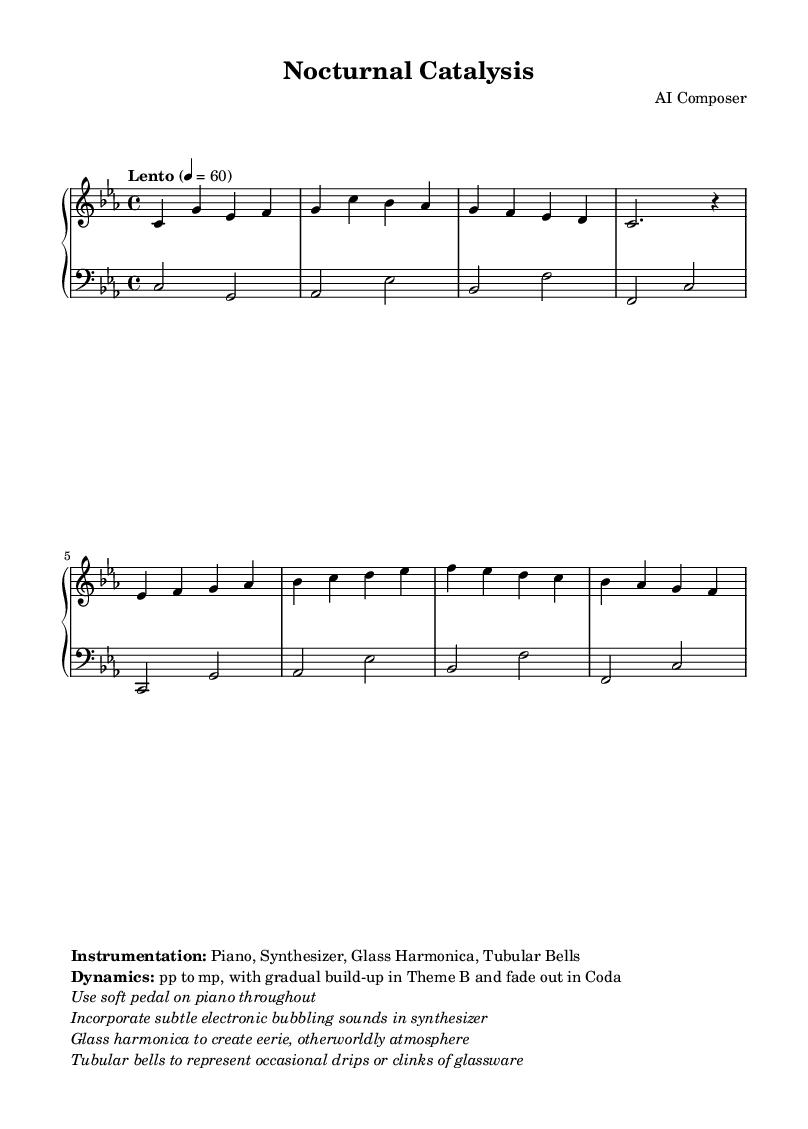What is the key signature of this music? The key signature is C minor, which has three flats (B♭, E♭, A♭). This can be determined by looking at the key signature marking at the beginning of the staff.
Answer: C minor What is the time signature of the piece? The time signature is 4/4, indicating that there are four beats in a measure and a quarter note gets one beat. This can be observed in the time signature marking at the beginning of the score.
Answer: 4/4 What is the tempo marking of the music? The tempo marking is "Lento," which means slowly. This is specified in the tempo indication at the beginning of the score, with the metronome marking of 60 beats per minute.
Answer: Lento How many instruments are specified in the instrumentation? The sheet music specifies four instruments: Piano, Synthesizer, Glass Harmonica, and Tubular Bells. This information is provided in the markup section where instrumentation is listed.
Answer: Four What dynamic markings are indicated in the score? The dynamic markings indicate "pp to mp" which refers to piano (soft) to mezzo-piano (moderately soft). This detail is found in the dynamics section of the markup.
Answer: pp to mp What unique atmospheric element is suggested by the Glass Harmonica? The Glass Harmonica is mentioned to create an "eerie, otherworldly atmosphere." This description is part of the performance notes and highlights the intended emotional effect of using the instrument.
Answer: Eerie atmosphere During which section does the music indicate a gradual build-up? The markup specifically mentions a gradual build-up in "Theme B." This implies that the dynamics or intensity will increase throughout this section.
Answer: Theme B 